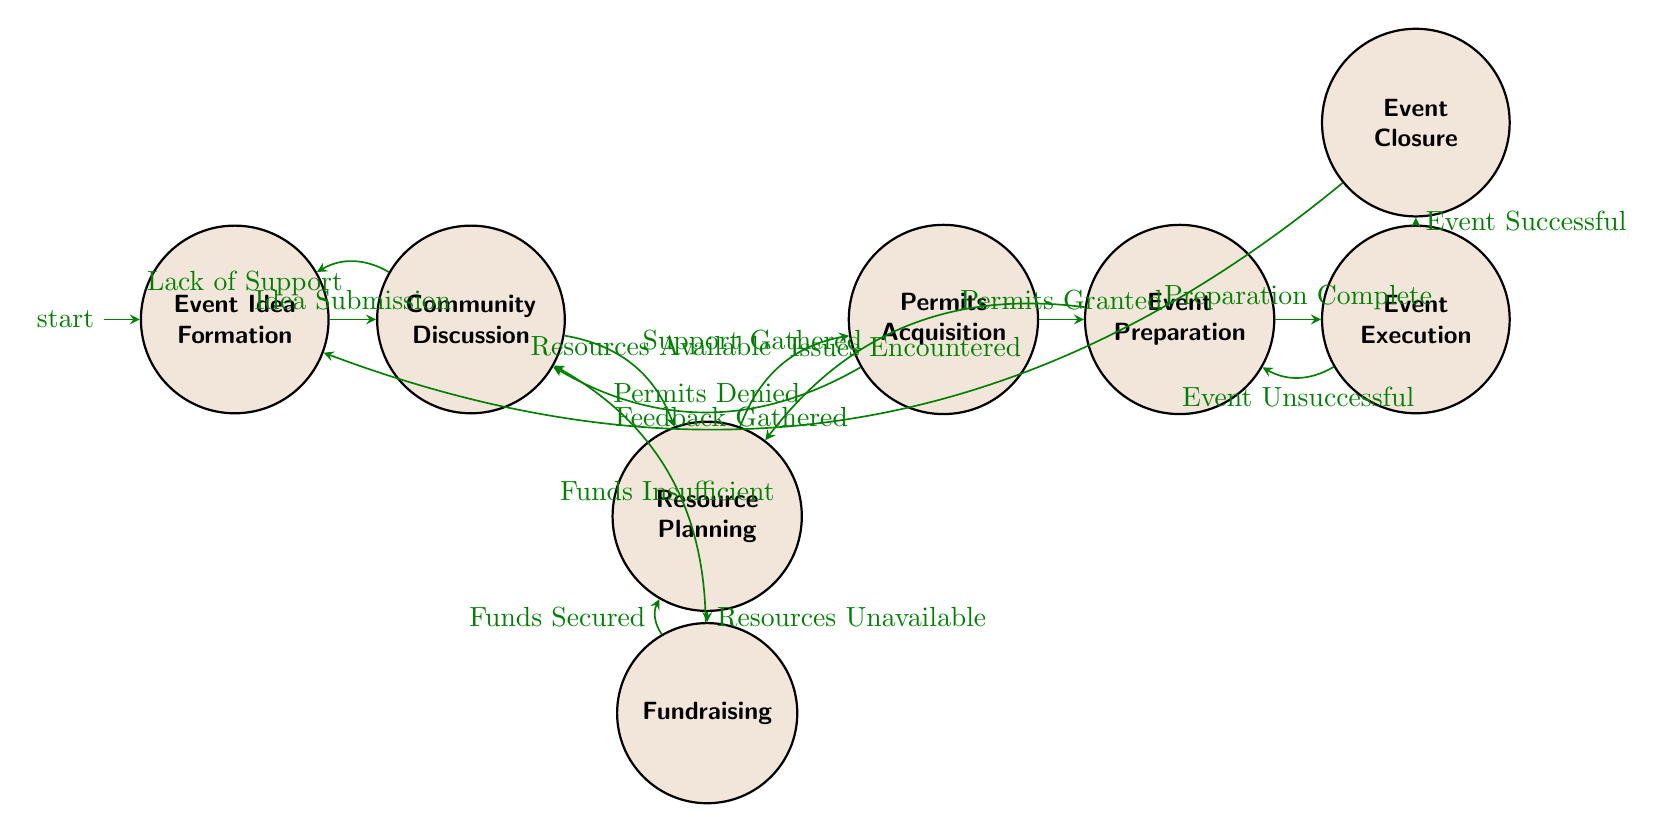What's the initial state of the workflow? The initial state is depicted as the starting point in the diagram, marked as "Event Idea Formation."
Answer: Event Idea Formation How many states are represented in the diagram? By counting each unique node in the diagram, I find there are seven states total: Event Idea Formation, Community Discussion, Resource Planning, Fundraising, Permits Acquisition, Event Preparation, and Event Execution, and Event Closure.
Answer: 7 What happens if there is a lack of support during the community discussion? If there is a lack of support in the Community Discussion, the flow leads back to the Event Idea Formation state, indicating a need to revisit and possibly rework the initial idea.
Answer: Event Idea Formation What event leads to permits acquisition? The transition to Permits Acquisition occurs when the resources available condition is met during Resource Planning, signifying readiness for the permits process.
Answer: Resources Available What does the diagram represent? The overall structure depicts a finite state machine that outlines the workflow for organizing a community event, showcasing different stages of planning and execution.
Answer: Organizing Community Event Workflow What is the final state after receiving feedback? After gathering feedback, the workflow returns to the initial state of Event Idea Formation, suggesting that insights will be considered for future events.
Answer: Event Idea Formation What is the outcome if the event is unsuccessful? If the Event Execution results in an unsuccessful outcome, the workflow loops back to Event Preparation, indicating a need to address issues and reattempt preparation steps.
Answer: Event Preparation Which state follows the permits acquisition if permits are granted? Upon receiving granted permits, the workflow progresses to the next stage which is Event Preparation, marking the transition to preparing for the event.
Answer: Event Preparation 